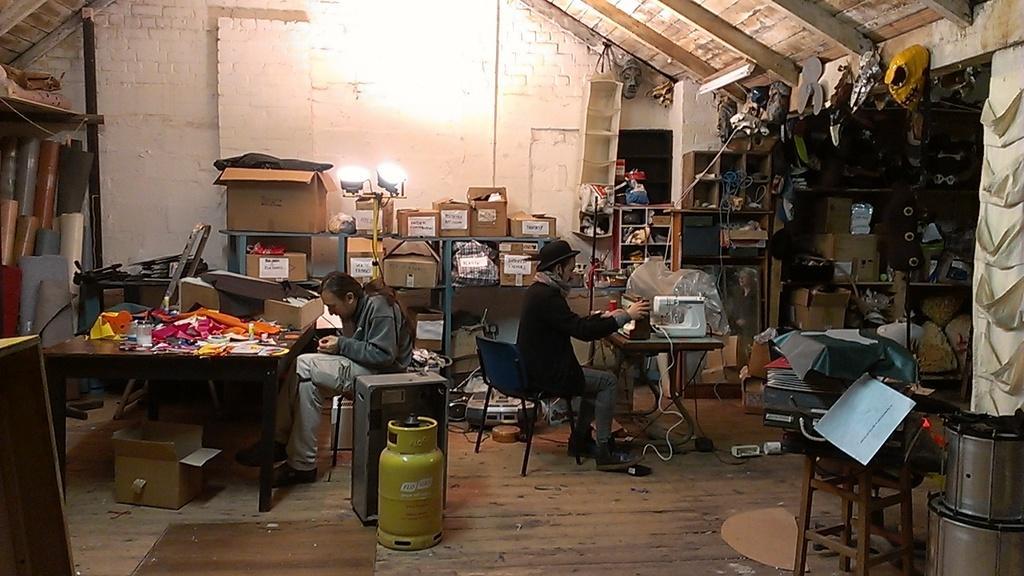Can you describe this image briefly? An indoor picture. This are cardboard boxes. This is light. A rack. This 2 persons are sitting on a chair. In-front of this person there is a table. In-front of this person there is a table and sewing machine. This are drum. 